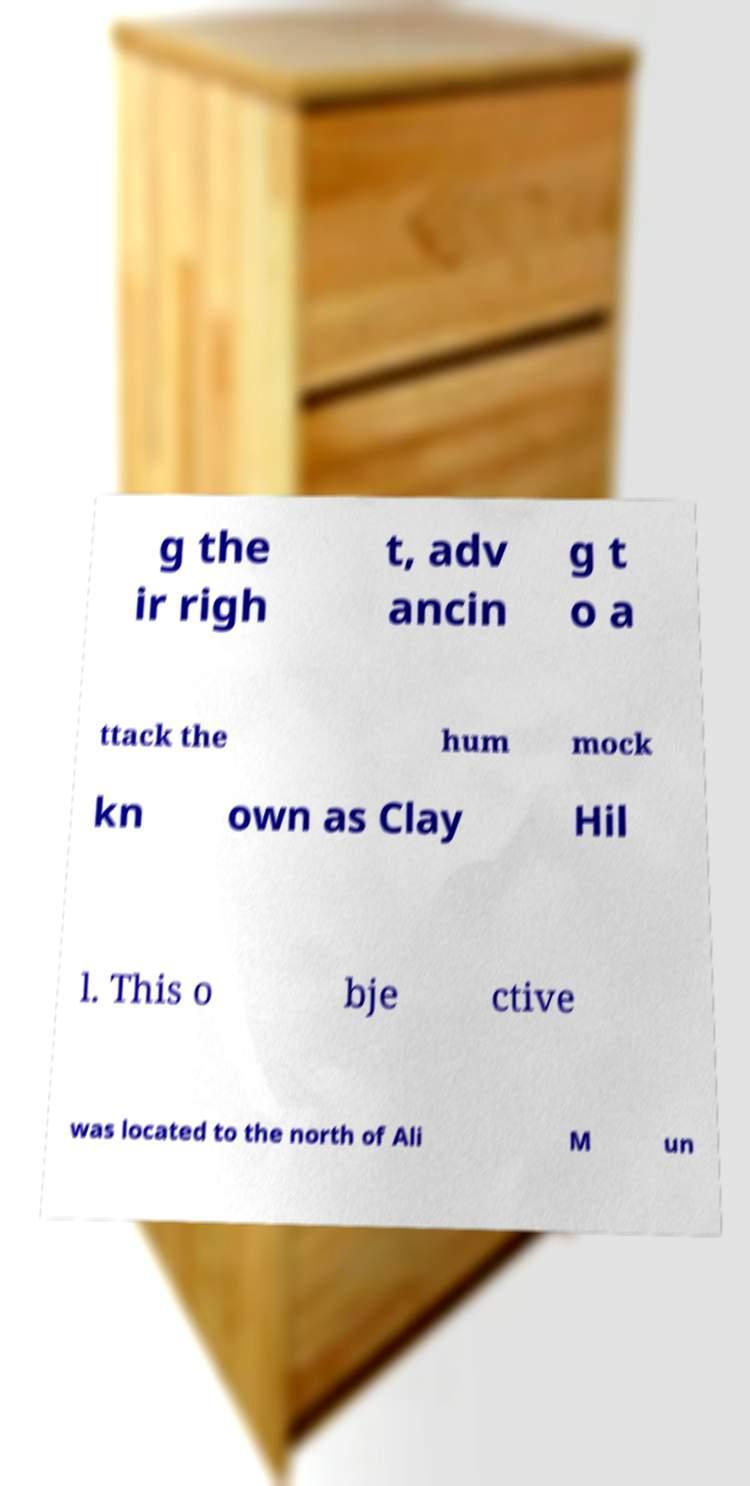Could you extract and type out the text from this image? g the ir righ t, adv ancin g t o a ttack the hum mock kn own as Clay Hil l. This o bje ctive was located to the north of Ali M un 